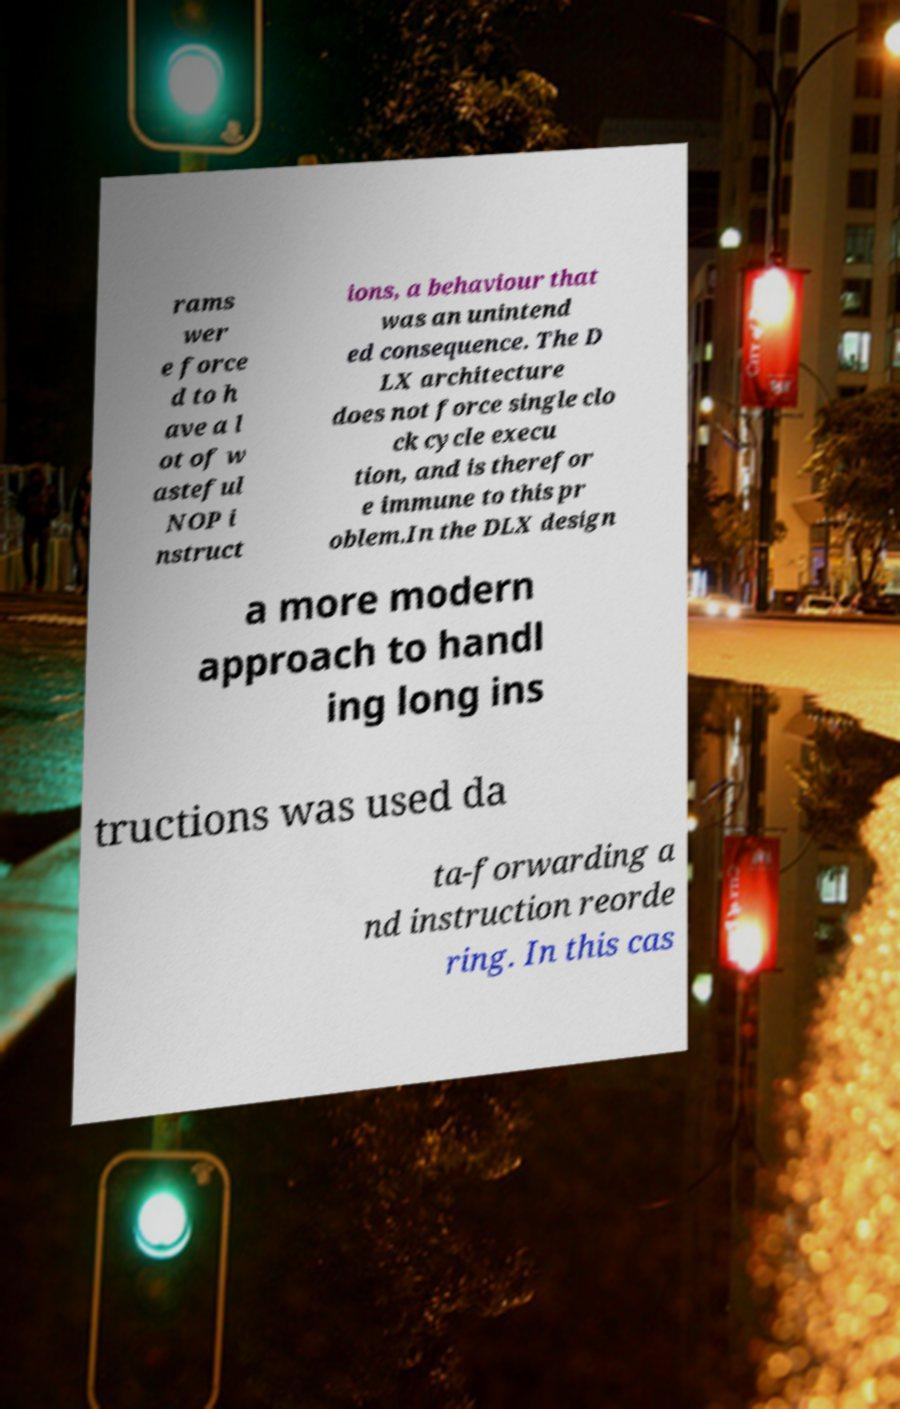There's text embedded in this image that I need extracted. Can you transcribe it verbatim? rams wer e force d to h ave a l ot of w asteful NOP i nstruct ions, a behaviour that was an unintend ed consequence. The D LX architecture does not force single clo ck cycle execu tion, and is therefor e immune to this pr oblem.In the DLX design a more modern approach to handl ing long ins tructions was used da ta-forwarding a nd instruction reorde ring. In this cas 